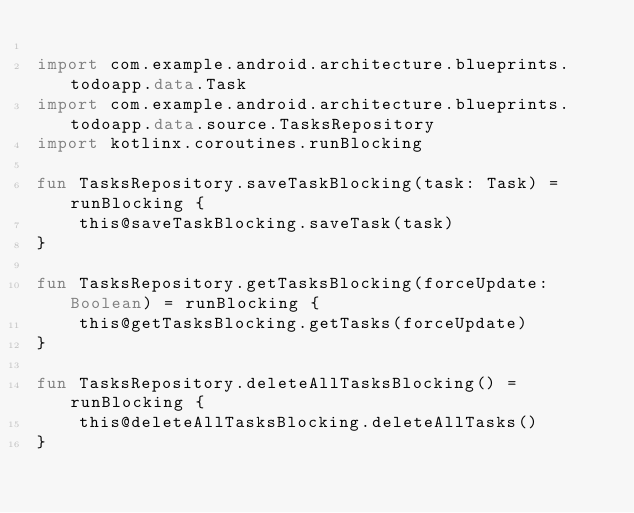Convert code to text. <code><loc_0><loc_0><loc_500><loc_500><_Kotlin_>
import com.example.android.architecture.blueprints.todoapp.data.Task
import com.example.android.architecture.blueprints.todoapp.data.source.TasksRepository
import kotlinx.coroutines.runBlocking

fun TasksRepository.saveTaskBlocking(task: Task) = runBlocking {
    this@saveTaskBlocking.saveTask(task)
}

fun TasksRepository.getTasksBlocking(forceUpdate: Boolean) = runBlocking {
    this@getTasksBlocking.getTasks(forceUpdate)
}

fun TasksRepository.deleteAllTasksBlocking() = runBlocking {
    this@deleteAllTasksBlocking.deleteAllTasks()
}</code> 